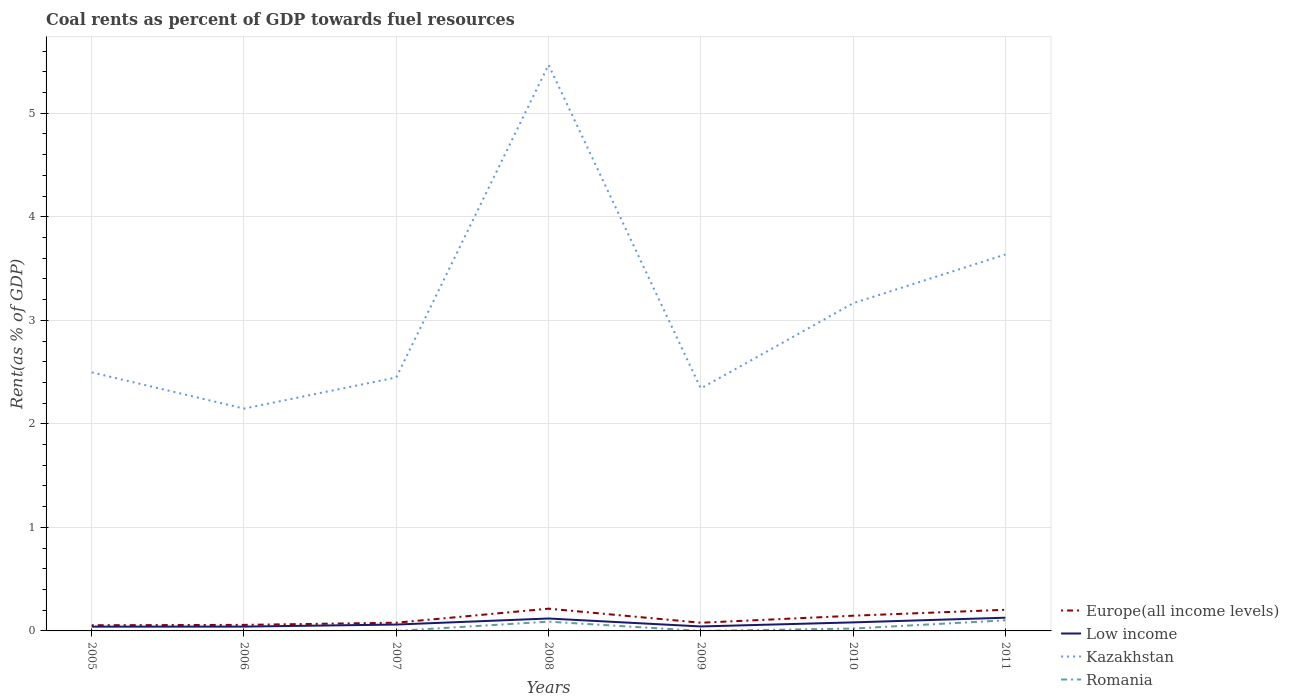Does the line corresponding to Europe(all income levels) intersect with the line corresponding to Low income?
Provide a short and direct response. No. Is the number of lines equal to the number of legend labels?
Offer a very short reply. Yes. Across all years, what is the maximum coal rent in Europe(all income levels)?
Ensure brevity in your answer.  0.05. In which year was the coal rent in Romania maximum?
Your answer should be very brief. 2006. What is the total coal rent in Europe(all income levels) in the graph?
Ensure brevity in your answer.  -0.02. What is the difference between the highest and the second highest coal rent in Europe(all income levels)?
Make the answer very short. 0.16. Is the coal rent in Low income strictly greater than the coal rent in Kazakhstan over the years?
Your answer should be compact. Yes. How many lines are there?
Give a very brief answer. 4. How many years are there in the graph?
Offer a terse response. 7. What is the difference between two consecutive major ticks on the Y-axis?
Offer a very short reply. 1. Does the graph contain grids?
Make the answer very short. Yes. Where does the legend appear in the graph?
Keep it short and to the point. Bottom right. How many legend labels are there?
Provide a succinct answer. 4. What is the title of the graph?
Your answer should be very brief. Coal rents as percent of GDP towards fuel resources. What is the label or title of the X-axis?
Your answer should be very brief. Years. What is the label or title of the Y-axis?
Provide a short and direct response. Rent(as % of GDP). What is the Rent(as % of GDP) of Europe(all income levels) in 2005?
Make the answer very short. 0.05. What is the Rent(as % of GDP) in Low income in 2005?
Provide a succinct answer. 0.04. What is the Rent(as % of GDP) in Kazakhstan in 2005?
Offer a terse response. 2.5. What is the Rent(as % of GDP) in Romania in 2005?
Offer a terse response. 8.7275933629083e-5. What is the Rent(as % of GDP) of Europe(all income levels) in 2006?
Your answer should be compact. 0.06. What is the Rent(as % of GDP) of Low income in 2006?
Offer a very short reply. 0.04. What is the Rent(as % of GDP) in Kazakhstan in 2006?
Provide a short and direct response. 2.15. What is the Rent(as % of GDP) in Romania in 2006?
Provide a succinct answer. 7.42123758365009e-5. What is the Rent(as % of GDP) in Europe(all income levels) in 2007?
Ensure brevity in your answer.  0.08. What is the Rent(as % of GDP) of Low income in 2007?
Provide a succinct answer. 0.06. What is the Rent(as % of GDP) in Kazakhstan in 2007?
Provide a short and direct response. 2.45. What is the Rent(as % of GDP) in Romania in 2007?
Ensure brevity in your answer.  9.89979329873995e-5. What is the Rent(as % of GDP) in Europe(all income levels) in 2008?
Your answer should be very brief. 0.21. What is the Rent(as % of GDP) in Low income in 2008?
Provide a short and direct response. 0.12. What is the Rent(as % of GDP) in Kazakhstan in 2008?
Provide a succinct answer. 5.47. What is the Rent(as % of GDP) of Romania in 2008?
Keep it short and to the point. 0.09. What is the Rent(as % of GDP) in Europe(all income levels) in 2009?
Your response must be concise. 0.08. What is the Rent(as % of GDP) of Low income in 2009?
Make the answer very short. 0.04. What is the Rent(as % of GDP) in Kazakhstan in 2009?
Your response must be concise. 2.34. What is the Rent(as % of GDP) in Romania in 2009?
Keep it short and to the point. 9.91154234092374e-5. What is the Rent(as % of GDP) of Europe(all income levels) in 2010?
Ensure brevity in your answer.  0.15. What is the Rent(as % of GDP) in Low income in 2010?
Keep it short and to the point. 0.08. What is the Rent(as % of GDP) in Kazakhstan in 2010?
Your answer should be compact. 3.16. What is the Rent(as % of GDP) of Romania in 2010?
Ensure brevity in your answer.  0.02. What is the Rent(as % of GDP) in Europe(all income levels) in 2011?
Provide a short and direct response. 0.2. What is the Rent(as % of GDP) in Low income in 2011?
Your response must be concise. 0.13. What is the Rent(as % of GDP) of Kazakhstan in 2011?
Provide a succinct answer. 3.64. What is the Rent(as % of GDP) of Romania in 2011?
Make the answer very short. 0.1. Across all years, what is the maximum Rent(as % of GDP) of Europe(all income levels)?
Ensure brevity in your answer.  0.21. Across all years, what is the maximum Rent(as % of GDP) in Low income?
Provide a succinct answer. 0.13. Across all years, what is the maximum Rent(as % of GDP) in Kazakhstan?
Your response must be concise. 5.47. Across all years, what is the maximum Rent(as % of GDP) in Romania?
Your answer should be compact. 0.1. Across all years, what is the minimum Rent(as % of GDP) of Europe(all income levels)?
Ensure brevity in your answer.  0.05. Across all years, what is the minimum Rent(as % of GDP) in Low income?
Your answer should be compact. 0.04. Across all years, what is the minimum Rent(as % of GDP) of Kazakhstan?
Your answer should be very brief. 2.15. Across all years, what is the minimum Rent(as % of GDP) in Romania?
Give a very brief answer. 7.42123758365009e-5. What is the total Rent(as % of GDP) in Europe(all income levels) in the graph?
Give a very brief answer. 0.84. What is the total Rent(as % of GDP) in Low income in the graph?
Give a very brief answer. 0.52. What is the total Rent(as % of GDP) of Kazakhstan in the graph?
Keep it short and to the point. 21.7. What is the total Rent(as % of GDP) of Romania in the graph?
Your response must be concise. 0.22. What is the difference between the Rent(as % of GDP) in Europe(all income levels) in 2005 and that in 2006?
Make the answer very short. -0. What is the difference between the Rent(as % of GDP) in Low income in 2005 and that in 2006?
Ensure brevity in your answer.  -0. What is the difference between the Rent(as % of GDP) of Kazakhstan in 2005 and that in 2006?
Provide a short and direct response. 0.35. What is the difference between the Rent(as % of GDP) in Europe(all income levels) in 2005 and that in 2007?
Provide a succinct answer. -0.02. What is the difference between the Rent(as % of GDP) of Low income in 2005 and that in 2007?
Make the answer very short. -0.02. What is the difference between the Rent(as % of GDP) in Kazakhstan in 2005 and that in 2007?
Provide a short and direct response. 0.05. What is the difference between the Rent(as % of GDP) of Romania in 2005 and that in 2007?
Make the answer very short. -0. What is the difference between the Rent(as % of GDP) in Europe(all income levels) in 2005 and that in 2008?
Your answer should be very brief. -0.16. What is the difference between the Rent(as % of GDP) in Low income in 2005 and that in 2008?
Provide a short and direct response. -0.08. What is the difference between the Rent(as % of GDP) in Kazakhstan in 2005 and that in 2008?
Provide a short and direct response. -2.97. What is the difference between the Rent(as % of GDP) of Romania in 2005 and that in 2008?
Keep it short and to the point. -0.09. What is the difference between the Rent(as % of GDP) of Europe(all income levels) in 2005 and that in 2009?
Provide a short and direct response. -0.02. What is the difference between the Rent(as % of GDP) of Low income in 2005 and that in 2009?
Your answer should be compact. -0. What is the difference between the Rent(as % of GDP) of Kazakhstan in 2005 and that in 2009?
Provide a short and direct response. 0.16. What is the difference between the Rent(as % of GDP) in Romania in 2005 and that in 2009?
Offer a very short reply. -0. What is the difference between the Rent(as % of GDP) in Europe(all income levels) in 2005 and that in 2010?
Keep it short and to the point. -0.09. What is the difference between the Rent(as % of GDP) of Low income in 2005 and that in 2010?
Give a very brief answer. -0.04. What is the difference between the Rent(as % of GDP) of Kazakhstan in 2005 and that in 2010?
Offer a very short reply. -0.67. What is the difference between the Rent(as % of GDP) in Romania in 2005 and that in 2010?
Your answer should be very brief. -0.02. What is the difference between the Rent(as % of GDP) in Europe(all income levels) in 2005 and that in 2011?
Keep it short and to the point. -0.15. What is the difference between the Rent(as % of GDP) of Low income in 2005 and that in 2011?
Offer a terse response. -0.09. What is the difference between the Rent(as % of GDP) in Kazakhstan in 2005 and that in 2011?
Offer a very short reply. -1.14. What is the difference between the Rent(as % of GDP) of Romania in 2005 and that in 2011?
Offer a very short reply. -0.1. What is the difference between the Rent(as % of GDP) in Europe(all income levels) in 2006 and that in 2007?
Give a very brief answer. -0.02. What is the difference between the Rent(as % of GDP) of Low income in 2006 and that in 2007?
Provide a succinct answer. -0.02. What is the difference between the Rent(as % of GDP) of Kazakhstan in 2006 and that in 2007?
Your response must be concise. -0.3. What is the difference between the Rent(as % of GDP) in Europe(all income levels) in 2006 and that in 2008?
Offer a terse response. -0.16. What is the difference between the Rent(as % of GDP) in Low income in 2006 and that in 2008?
Offer a terse response. -0.08. What is the difference between the Rent(as % of GDP) in Kazakhstan in 2006 and that in 2008?
Offer a terse response. -3.32. What is the difference between the Rent(as % of GDP) of Romania in 2006 and that in 2008?
Provide a short and direct response. -0.09. What is the difference between the Rent(as % of GDP) in Europe(all income levels) in 2006 and that in 2009?
Provide a short and direct response. -0.02. What is the difference between the Rent(as % of GDP) in Low income in 2006 and that in 2009?
Your answer should be very brief. -0. What is the difference between the Rent(as % of GDP) of Kazakhstan in 2006 and that in 2009?
Your answer should be compact. -0.19. What is the difference between the Rent(as % of GDP) of Romania in 2006 and that in 2009?
Provide a succinct answer. -0. What is the difference between the Rent(as % of GDP) of Europe(all income levels) in 2006 and that in 2010?
Give a very brief answer. -0.09. What is the difference between the Rent(as % of GDP) of Low income in 2006 and that in 2010?
Your response must be concise. -0.04. What is the difference between the Rent(as % of GDP) of Kazakhstan in 2006 and that in 2010?
Your answer should be very brief. -1.02. What is the difference between the Rent(as % of GDP) in Romania in 2006 and that in 2010?
Provide a succinct answer. -0.02. What is the difference between the Rent(as % of GDP) of Europe(all income levels) in 2006 and that in 2011?
Give a very brief answer. -0.15. What is the difference between the Rent(as % of GDP) in Low income in 2006 and that in 2011?
Make the answer very short. -0.09. What is the difference between the Rent(as % of GDP) of Kazakhstan in 2006 and that in 2011?
Keep it short and to the point. -1.49. What is the difference between the Rent(as % of GDP) of Romania in 2006 and that in 2011?
Provide a short and direct response. -0.1. What is the difference between the Rent(as % of GDP) of Europe(all income levels) in 2007 and that in 2008?
Provide a short and direct response. -0.14. What is the difference between the Rent(as % of GDP) in Low income in 2007 and that in 2008?
Offer a very short reply. -0.06. What is the difference between the Rent(as % of GDP) of Kazakhstan in 2007 and that in 2008?
Offer a very short reply. -3.02. What is the difference between the Rent(as % of GDP) in Romania in 2007 and that in 2008?
Make the answer very short. -0.09. What is the difference between the Rent(as % of GDP) in Low income in 2007 and that in 2009?
Ensure brevity in your answer.  0.02. What is the difference between the Rent(as % of GDP) in Kazakhstan in 2007 and that in 2009?
Your response must be concise. 0.11. What is the difference between the Rent(as % of GDP) in Europe(all income levels) in 2007 and that in 2010?
Provide a short and direct response. -0.07. What is the difference between the Rent(as % of GDP) in Low income in 2007 and that in 2010?
Your answer should be compact. -0.02. What is the difference between the Rent(as % of GDP) in Kazakhstan in 2007 and that in 2010?
Keep it short and to the point. -0.72. What is the difference between the Rent(as % of GDP) of Romania in 2007 and that in 2010?
Your response must be concise. -0.02. What is the difference between the Rent(as % of GDP) of Europe(all income levels) in 2007 and that in 2011?
Your answer should be very brief. -0.12. What is the difference between the Rent(as % of GDP) in Low income in 2007 and that in 2011?
Make the answer very short. -0.07. What is the difference between the Rent(as % of GDP) in Kazakhstan in 2007 and that in 2011?
Make the answer very short. -1.19. What is the difference between the Rent(as % of GDP) of Romania in 2007 and that in 2011?
Keep it short and to the point. -0.1. What is the difference between the Rent(as % of GDP) of Europe(all income levels) in 2008 and that in 2009?
Your response must be concise. 0.14. What is the difference between the Rent(as % of GDP) in Low income in 2008 and that in 2009?
Offer a very short reply. 0.08. What is the difference between the Rent(as % of GDP) in Kazakhstan in 2008 and that in 2009?
Offer a very short reply. 3.12. What is the difference between the Rent(as % of GDP) in Romania in 2008 and that in 2009?
Provide a short and direct response. 0.09. What is the difference between the Rent(as % of GDP) in Europe(all income levels) in 2008 and that in 2010?
Your answer should be very brief. 0.07. What is the difference between the Rent(as % of GDP) of Low income in 2008 and that in 2010?
Offer a very short reply. 0.04. What is the difference between the Rent(as % of GDP) of Kazakhstan in 2008 and that in 2010?
Provide a succinct answer. 2.3. What is the difference between the Rent(as % of GDP) in Romania in 2008 and that in 2010?
Your answer should be very brief. 0.07. What is the difference between the Rent(as % of GDP) in Europe(all income levels) in 2008 and that in 2011?
Offer a very short reply. 0.01. What is the difference between the Rent(as % of GDP) of Low income in 2008 and that in 2011?
Offer a terse response. -0.01. What is the difference between the Rent(as % of GDP) of Kazakhstan in 2008 and that in 2011?
Ensure brevity in your answer.  1.83. What is the difference between the Rent(as % of GDP) in Romania in 2008 and that in 2011?
Make the answer very short. -0.01. What is the difference between the Rent(as % of GDP) in Europe(all income levels) in 2009 and that in 2010?
Make the answer very short. -0.07. What is the difference between the Rent(as % of GDP) of Low income in 2009 and that in 2010?
Offer a terse response. -0.04. What is the difference between the Rent(as % of GDP) in Kazakhstan in 2009 and that in 2010?
Provide a succinct answer. -0.82. What is the difference between the Rent(as % of GDP) in Romania in 2009 and that in 2010?
Keep it short and to the point. -0.02. What is the difference between the Rent(as % of GDP) of Europe(all income levels) in 2009 and that in 2011?
Your answer should be very brief. -0.13. What is the difference between the Rent(as % of GDP) of Low income in 2009 and that in 2011?
Your answer should be very brief. -0.08. What is the difference between the Rent(as % of GDP) in Kazakhstan in 2009 and that in 2011?
Your answer should be very brief. -1.29. What is the difference between the Rent(as % of GDP) in Romania in 2009 and that in 2011?
Provide a short and direct response. -0.1. What is the difference between the Rent(as % of GDP) of Europe(all income levels) in 2010 and that in 2011?
Provide a short and direct response. -0.06. What is the difference between the Rent(as % of GDP) of Low income in 2010 and that in 2011?
Ensure brevity in your answer.  -0.05. What is the difference between the Rent(as % of GDP) of Kazakhstan in 2010 and that in 2011?
Make the answer very short. -0.47. What is the difference between the Rent(as % of GDP) in Romania in 2010 and that in 2011?
Your response must be concise. -0.08. What is the difference between the Rent(as % of GDP) in Europe(all income levels) in 2005 and the Rent(as % of GDP) in Low income in 2006?
Make the answer very short. 0.01. What is the difference between the Rent(as % of GDP) in Europe(all income levels) in 2005 and the Rent(as % of GDP) in Kazakhstan in 2006?
Ensure brevity in your answer.  -2.09. What is the difference between the Rent(as % of GDP) in Europe(all income levels) in 2005 and the Rent(as % of GDP) in Romania in 2006?
Make the answer very short. 0.05. What is the difference between the Rent(as % of GDP) in Low income in 2005 and the Rent(as % of GDP) in Kazakhstan in 2006?
Your response must be concise. -2.11. What is the difference between the Rent(as % of GDP) of Low income in 2005 and the Rent(as % of GDP) of Romania in 2006?
Make the answer very short. 0.04. What is the difference between the Rent(as % of GDP) of Kazakhstan in 2005 and the Rent(as % of GDP) of Romania in 2006?
Your answer should be compact. 2.5. What is the difference between the Rent(as % of GDP) of Europe(all income levels) in 2005 and the Rent(as % of GDP) of Low income in 2007?
Provide a short and direct response. -0.01. What is the difference between the Rent(as % of GDP) in Europe(all income levels) in 2005 and the Rent(as % of GDP) in Kazakhstan in 2007?
Provide a succinct answer. -2.39. What is the difference between the Rent(as % of GDP) in Europe(all income levels) in 2005 and the Rent(as % of GDP) in Romania in 2007?
Give a very brief answer. 0.05. What is the difference between the Rent(as % of GDP) of Low income in 2005 and the Rent(as % of GDP) of Kazakhstan in 2007?
Make the answer very short. -2.41. What is the difference between the Rent(as % of GDP) in Low income in 2005 and the Rent(as % of GDP) in Romania in 2007?
Your response must be concise. 0.04. What is the difference between the Rent(as % of GDP) in Kazakhstan in 2005 and the Rent(as % of GDP) in Romania in 2007?
Your response must be concise. 2.5. What is the difference between the Rent(as % of GDP) in Europe(all income levels) in 2005 and the Rent(as % of GDP) in Low income in 2008?
Keep it short and to the point. -0.07. What is the difference between the Rent(as % of GDP) of Europe(all income levels) in 2005 and the Rent(as % of GDP) of Kazakhstan in 2008?
Your answer should be compact. -5.41. What is the difference between the Rent(as % of GDP) in Europe(all income levels) in 2005 and the Rent(as % of GDP) in Romania in 2008?
Provide a short and direct response. -0.03. What is the difference between the Rent(as % of GDP) in Low income in 2005 and the Rent(as % of GDP) in Kazakhstan in 2008?
Offer a very short reply. -5.43. What is the difference between the Rent(as % of GDP) in Low income in 2005 and the Rent(as % of GDP) in Romania in 2008?
Give a very brief answer. -0.05. What is the difference between the Rent(as % of GDP) in Kazakhstan in 2005 and the Rent(as % of GDP) in Romania in 2008?
Provide a succinct answer. 2.41. What is the difference between the Rent(as % of GDP) in Europe(all income levels) in 2005 and the Rent(as % of GDP) in Low income in 2009?
Keep it short and to the point. 0.01. What is the difference between the Rent(as % of GDP) of Europe(all income levels) in 2005 and the Rent(as % of GDP) of Kazakhstan in 2009?
Give a very brief answer. -2.29. What is the difference between the Rent(as % of GDP) of Europe(all income levels) in 2005 and the Rent(as % of GDP) of Romania in 2009?
Provide a succinct answer. 0.05. What is the difference between the Rent(as % of GDP) of Low income in 2005 and the Rent(as % of GDP) of Kazakhstan in 2009?
Offer a terse response. -2.3. What is the difference between the Rent(as % of GDP) of Low income in 2005 and the Rent(as % of GDP) of Romania in 2009?
Provide a succinct answer. 0.04. What is the difference between the Rent(as % of GDP) of Kazakhstan in 2005 and the Rent(as % of GDP) of Romania in 2009?
Make the answer very short. 2.5. What is the difference between the Rent(as % of GDP) in Europe(all income levels) in 2005 and the Rent(as % of GDP) in Low income in 2010?
Give a very brief answer. -0.03. What is the difference between the Rent(as % of GDP) of Europe(all income levels) in 2005 and the Rent(as % of GDP) of Kazakhstan in 2010?
Keep it short and to the point. -3.11. What is the difference between the Rent(as % of GDP) in Europe(all income levels) in 2005 and the Rent(as % of GDP) in Romania in 2010?
Your answer should be very brief. 0.03. What is the difference between the Rent(as % of GDP) in Low income in 2005 and the Rent(as % of GDP) in Kazakhstan in 2010?
Offer a very short reply. -3.12. What is the difference between the Rent(as % of GDP) of Low income in 2005 and the Rent(as % of GDP) of Romania in 2010?
Your response must be concise. 0.02. What is the difference between the Rent(as % of GDP) in Kazakhstan in 2005 and the Rent(as % of GDP) in Romania in 2010?
Provide a short and direct response. 2.47. What is the difference between the Rent(as % of GDP) in Europe(all income levels) in 2005 and the Rent(as % of GDP) in Low income in 2011?
Make the answer very short. -0.07. What is the difference between the Rent(as % of GDP) in Europe(all income levels) in 2005 and the Rent(as % of GDP) in Kazakhstan in 2011?
Keep it short and to the point. -3.58. What is the difference between the Rent(as % of GDP) in Europe(all income levels) in 2005 and the Rent(as % of GDP) in Romania in 2011?
Give a very brief answer. -0.05. What is the difference between the Rent(as % of GDP) of Low income in 2005 and the Rent(as % of GDP) of Kazakhstan in 2011?
Make the answer very short. -3.59. What is the difference between the Rent(as % of GDP) in Low income in 2005 and the Rent(as % of GDP) in Romania in 2011?
Ensure brevity in your answer.  -0.06. What is the difference between the Rent(as % of GDP) of Kazakhstan in 2005 and the Rent(as % of GDP) of Romania in 2011?
Your response must be concise. 2.39. What is the difference between the Rent(as % of GDP) in Europe(all income levels) in 2006 and the Rent(as % of GDP) in Low income in 2007?
Offer a very short reply. -0. What is the difference between the Rent(as % of GDP) of Europe(all income levels) in 2006 and the Rent(as % of GDP) of Kazakhstan in 2007?
Ensure brevity in your answer.  -2.39. What is the difference between the Rent(as % of GDP) of Europe(all income levels) in 2006 and the Rent(as % of GDP) of Romania in 2007?
Provide a short and direct response. 0.06. What is the difference between the Rent(as % of GDP) in Low income in 2006 and the Rent(as % of GDP) in Kazakhstan in 2007?
Make the answer very short. -2.41. What is the difference between the Rent(as % of GDP) of Low income in 2006 and the Rent(as % of GDP) of Romania in 2007?
Ensure brevity in your answer.  0.04. What is the difference between the Rent(as % of GDP) of Kazakhstan in 2006 and the Rent(as % of GDP) of Romania in 2007?
Ensure brevity in your answer.  2.15. What is the difference between the Rent(as % of GDP) of Europe(all income levels) in 2006 and the Rent(as % of GDP) of Low income in 2008?
Your response must be concise. -0.06. What is the difference between the Rent(as % of GDP) of Europe(all income levels) in 2006 and the Rent(as % of GDP) of Kazakhstan in 2008?
Keep it short and to the point. -5.41. What is the difference between the Rent(as % of GDP) of Europe(all income levels) in 2006 and the Rent(as % of GDP) of Romania in 2008?
Make the answer very short. -0.03. What is the difference between the Rent(as % of GDP) in Low income in 2006 and the Rent(as % of GDP) in Kazakhstan in 2008?
Your answer should be compact. -5.43. What is the difference between the Rent(as % of GDP) in Low income in 2006 and the Rent(as % of GDP) in Romania in 2008?
Ensure brevity in your answer.  -0.05. What is the difference between the Rent(as % of GDP) in Kazakhstan in 2006 and the Rent(as % of GDP) in Romania in 2008?
Give a very brief answer. 2.06. What is the difference between the Rent(as % of GDP) of Europe(all income levels) in 2006 and the Rent(as % of GDP) of Low income in 2009?
Offer a very short reply. 0.02. What is the difference between the Rent(as % of GDP) of Europe(all income levels) in 2006 and the Rent(as % of GDP) of Kazakhstan in 2009?
Make the answer very short. -2.28. What is the difference between the Rent(as % of GDP) of Europe(all income levels) in 2006 and the Rent(as % of GDP) of Romania in 2009?
Offer a very short reply. 0.06. What is the difference between the Rent(as % of GDP) in Low income in 2006 and the Rent(as % of GDP) in Kazakhstan in 2009?
Offer a terse response. -2.3. What is the difference between the Rent(as % of GDP) of Low income in 2006 and the Rent(as % of GDP) of Romania in 2009?
Your response must be concise. 0.04. What is the difference between the Rent(as % of GDP) in Kazakhstan in 2006 and the Rent(as % of GDP) in Romania in 2009?
Offer a very short reply. 2.15. What is the difference between the Rent(as % of GDP) of Europe(all income levels) in 2006 and the Rent(as % of GDP) of Low income in 2010?
Keep it short and to the point. -0.02. What is the difference between the Rent(as % of GDP) in Europe(all income levels) in 2006 and the Rent(as % of GDP) in Kazakhstan in 2010?
Your response must be concise. -3.11. What is the difference between the Rent(as % of GDP) in Europe(all income levels) in 2006 and the Rent(as % of GDP) in Romania in 2010?
Keep it short and to the point. 0.04. What is the difference between the Rent(as % of GDP) of Low income in 2006 and the Rent(as % of GDP) of Kazakhstan in 2010?
Make the answer very short. -3.12. What is the difference between the Rent(as % of GDP) in Low income in 2006 and the Rent(as % of GDP) in Romania in 2010?
Offer a terse response. 0.02. What is the difference between the Rent(as % of GDP) of Kazakhstan in 2006 and the Rent(as % of GDP) of Romania in 2010?
Your answer should be compact. 2.12. What is the difference between the Rent(as % of GDP) in Europe(all income levels) in 2006 and the Rent(as % of GDP) in Low income in 2011?
Your answer should be very brief. -0.07. What is the difference between the Rent(as % of GDP) of Europe(all income levels) in 2006 and the Rent(as % of GDP) of Kazakhstan in 2011?
Make the answer very short. -3.58. What is the difference between the Rent(as % of GDP) of Europe(all income levels) in 2006 and the Rent(as % of GDP) of Romania in 2011?
Your answer should be compact. -0.04. What is the difference between the Rent(as % of GDP) in Low income in 2006 and the Rent(as % of GDP) in Kazakhstan in 2011?
Keep it short and to the point. -3.59. What is the difference between the Rent(as % of GDP) of Low income in 2006 and the Rent(as % of GDP) of Romania in 2011?
Make the answer very short. -0.06. What is the difference between the Rent(as % of GDP) in Kazakhstan in 2006 and the Rent(as % of GDP) in Romania in 2011?
Provide a short and direct response. 2.04. What is the difference between the Rent(as % of GDP) of Europe(all income levels) in 2007 and the Rent(as % of GDP) of Low income in 2008?
Provide a succinct answer. -0.04. What is the difference between the Rent(as % of GDP) in Europe(all income levels) in 2007 and the Rent(as % of GDP) in Kazakhstan in 2008?
Provide a succinct answer. -5.39. What is the difference between the Rent(as % of GDP) in Europe(all income levels) in 2007 and the Rent(as % of GDP) in Romania in 2008?
Ensure brevity in your answer.  -0.01. What is the difference between the Rent(as % of GDP) of Low income in 2007 and the Rent(as % of GDP) of Kazakhstan in 2008?
Provide a short and direct response. -5.41. What is the difference between the Rent(as % of GDP) in Low income in 2007 and the Rent(as % of GDP) in Romania in 2008?
Your response must be concise. -0.03. What is the difference between the Rent(as % of GDP) in Kazakhstan in 2007 and the Rent(as % of GDP) in Romania in 2008?
Offer a terse response. 2.36. What is the difference between the Rent(as % of GDP) in Europe(all income levels) in 2007 and the Rent(as % of GDP) in Low income in 2009?
Your answer should be very brief. 0.04. What is the difference between the Rent(as % of GDP) in Europe(all income levels) in 2007 and the Rent(as % of GDP) in Kazakhstan in 2009?
Make the answer very short. -2.26. What is the difference between the Rent(as % of GDP) in Europe(all income levels) in 2007 and the Rent(as % of GDP) in Romania in 2009?
Keep it short and to the point. 0.08. What is the difference between the Rent(as % of GDP) in Low income in 2007 and the Rent(as % of GDP) in Kazakhstan in 2009?
Give a very brief answer. -2.28. What is the difference between the Rent(as % of GDP) in Low income in 2007 and the Rent(as % of GDP) in Romania in 2009?
Give a very brief answer. 0.06. What is the difference between the Rent(as % of GDP) of Kazakhstan in 2007 and the Rent(as % of GDP) of Romania in 2009?
Offer a very short reply. 2.45. What is the difference between the Rent(as % of GDP) of Europe(all income levels) in 2007 and the Rent(as % of GDP) of Low income in 2010?
Your answer should be compact. -0. What is the difference between the Rent(as % of GDP) in Europe(all income levels) in 2007 and the Rent(as % of GDP) in Kazakhstan in 2010?
Give a very brief answer. -3.09. What is the difference between the Rent(as % of GDP) in Europe(all income levels) in 2007 and the Rent(as % of GDP) in Romania in 2010?
Keep it short and to the point. 0.06. What is the difference between the Rent(as % of GDP) of Low income in 2007 and the Rent(as % of GDP) of Kazakhstan in 2010?
Ensure brevity in your answer.  -3.1. What is the difference between the Rent(as % of GDP) in Low income in 2007 and the Rent(as % of GDP) in Romania in 2010?
Your answer should be compact. 0.04. What is the difference between the Rent(as % of GDP) of Kazakhstan in 2007 and the Rent(as % of GDP) of Romania in 2010?
Provide a short and direct response. 2.43. What is the difference between the Rent(as % of GDP) of Europe(all income levels) in 2007 and the Rent(as % of GDP) of Low income in 2011?
Provide a succinct answer. -0.05. What is the difference between the Rent(as % of GDP) in Europe(all income levels) in 2007 and the Rent(as % of GDP) in Kazakhstan in 2011?
Your answer should be compact. -3.56. What is the difference between the Rent(as % of GDP) of Europe(all income levels) in 2007 and the Rent(as % of GDP) of Romania in 2011?
Keep it short and to the point. -0.02. What is the difference between the Rent(as % of GDP) of Low income in 2007 and the Rent(as % of GDP) of Kazakhstan in 2011?
Keep it short and to the point. -3.57. What is the difference between the Rent(as % of GDP) of Low income in 2007 and the Rent(as % of GDP) of Romania in 2011?
Make the answer very short. -0.04. What is the difference between the Rent(as % of GDP) of Kazakhstan in 2007 and the Rent(as % of GDP) of Romania in 2011?
Give a very brief answer. 2.35. What is the difference between the Rent(as % of GDP) of Europe(all income levels) in 2008 and the Rent(as % of GDP) of Low income in 2009?
Your response must be concise. 0.17. What is the difference between the Rent(as % of GDP) of Europe(all income levels) in 2008 and the Rent(as % of GDP) of Kazakhstan in 2009?
Your answer should be very brief. -2.13. What is the difference between the Rent(as % of GDP) in Europe(all income levels) in 2008 and the Rent(as % of GDP) in Romania in 2009?
Your answer should be very brief. 0.21. What is the difference between the Rent(as % of GDP) of Low income in 2008 and the Rent(as % of GDP) of Kazakhstan in 2009?
Provide a succinct answer. -2.22. What is the difference between the Rent(as % of GDP) of Low income in 2008 and the Rent(as % of GDP) of Romania in 2009?
Offer a very short reply. 0.12. What is the difference between the Rent(as % of GDP) of Kazakhstan in 2008 and the Rent(as % of GDP) of Romania in 2009?
Ensure brevity in your answer.  5.47. What is the difference between the Rent(as % of GDP) of Europe(all income levels) in 2008 and the Rent(as % of GDP) of Low income in 2010?
Provide a succinct answer. 0.13. What is the difference between the Rent(as % of GDP) of Europe(all income levels) in 2008 and the Rent(as % of GDP) of Kazakhstan in 2010?
Your answer should be compact. -2.95. What is the difference between the Rent(as % of GDP) in Europe(all income levels) in 2008 and the Rent(as % of GDP) in Romania in 2010?
Your answer should be very brief. 0.19. What is the difference between the Rent(as % of GDP) of Low income in 2008 and the Rent(as % of GDP) of Kazakhstan in 2010?
Offer a terse response. -3.04. What is the difference between the Rent(as % of GDP) of Low income in 2008 and the Rent(as % of GDP) of Romania in 2010?
Offer a very short reply. 0.1. What is the difference between the Rent(as % of GDP) in Kazakhstan in 2008 and the Rent(as % of GDP) in Romania in 2010?
Provide a short and direct response. 5.44. What is the difference between the Rent(as % of GDP) in Europe(all income levels) in 2008 and the Rent(as % of GDP) in Low income in 2011?
Your answer should be compact. 0.09. What is the difference between the Rent(as % of GDP) in Europe(all income levels) in 2008 and the Rent(as % of GDP) in Kazakhstan in 2011?
Ensure brevity in your answer.  -3.42. What is the difference between the Rent(as % of GDP) of Europe(all income levels) in 2008 and the Rent(as % of GDP) of Romania in 2011?
Provide a succinct answer. 0.11. What is the difference between the Rent(as % of GDP) of Low income in 2008 and the Rent(as % of GDP) of Kazakhstan in 2011?
Provide a short and direct response. -3.52. What is the difference between the Rent(as % of GDP) in Low income in 2008 and the Rent(as % of GDP) in Romania in 2011?
Keep it short and to the point. 0.02. What is the difference between the Rent(as % of GDP) of Kazakhstan in 2008 and the Rent(as % of GDP) of Romania in 2011?
Keep it short and to the point. 5.36. What is the difference between the Rent(as % of GDP) of Europe(all income levels) in 2009 and the Rent(as % of GDP) of Low income in 2010?
Ensure brevity in your answer.  -0. What is the difference between the Rent(as % of GDP) of Europe(all income levels) in 2009 and the Rent(as % of GDP) of Kazakhstan in 2010?
Offer a terse response. -3.09. What is the difference between the Rent(as % of GDP) in Europe(all income levels) in 2009 and the Rent(as % of GDP) in Romania in 2010?
Your answer should be compact. 0.06. What is the difference between the Rent(as % of GDP) in Low income in 2009 and the Rent(as % of GDP) in Kazakhstan in 2010?
Ensure brevity in your answer.  -3.12. What is the difference between the Rent(as % of GDP) of Low income in 2009 and the Rent(as % of GDP) of Romania in 2010?
Offer a very short reply. 0.02. What is the difference between the Rent(as % of GDP) of Kazakhstan in 2009 and the Rent(as % of GDP) of Romania in 2010?
Make the answer very short. 2.32. What is the difference between the Rent(as % of GDP) of Europe(all income levels) in 2009 and the Rent(as % of GDP) of Low income in 2011?
Your answer should be compact. -0.05. What is the difference between the Rent(as % of GDP) of Europe(all income levels) in 2009 and the Rent(as % of GDP) of Kazakhstan in 2011?
Your answer should be compact. -3.56. What is the difference between the Rent(as % of GDP) in Europe(all income levels) in 2009 and the Rent(as % of GDP) in Romania in 2011?
Give a very brief answer. -0.02. What is the difference between the Rent(as % of GDP) of Low income in 2009 and the Rent(as % of GDP) of Kazakhstan in 2011?
Your response must be concise. -3.59. What is the difference between the Rent(as % of GDP) in Low income in 2009 and the Rent(as % of GDP) in Romania in 2011?
Your answer should be compact. -0.06. What is the difference between the Rent(as % of GDP) in Kazakhstan in 2009 and the Rent(as % of GDP) in Romania in 2011?
Your response must be concise. 2.24. What is the difference between the Rent(as % of GDP) in Europe(all income levels) in 2010 and the Rent(as % of GDP) in Low income in 2011?
Your response must be concise. 0.02. What is the difference between the Rent(as % of GDP) of Europe(all income levels) in 2010 and the Rent(as % of GDP) of Kazakhstan in 2011?
Offer a very short reply. -3.49. What is the difference between the Rent(as % of GDP) of Europe(all income levels) in 2010 and the Rent(as % of GDP) of Romania in 2011?
Provide a short and direct response. 0.04. What is the difference between the Rent(as % of GDP) in Low income in 2010 and the Rent(as % of GDP) in Kazakhstan in 2011?
Ensure brevity in your answer.  -3.55. What is the difference between the Rent(as % of GDP) in Low income in 2010 and the Rent(as % of GDP) in Romania in 2011?
Your answer should be compact. -0.02. What is the difference between the Rent(as % of GDP) of Kazakhstan in 2010 and the Rent(as % of GDP) of Romania in 2011?
Make the answer very short. 3.06. What is the average Rent(as % of GDP) in Europe(all income levels) per year?
Your answer should be very brief. 0.12. What is the average Rent(as % of GDP) in Low income per year?
Your answer should be very brief. 0.07. What is the average Rent(as % of GDP) of Kazakhstan per year?
Your answer should be very brief. 3.1. What is the average Rent(as % of GDP) in Romania per year?
Provide a short and direct response. 0.03. In the year 2005, what is the difference between the Rent(as % of GDP) in Europe(all income levels) and Rent(as % of GDP) in Low income?
Your response must be concise. 0.01. In the year 2005, what is the difference between the Rent(as % of GDP) of Europe(all income levels) and Rent(as % of GDP) of Kazakhstan?
Your response must be concise. -2.44. In the year 2005, what is the difference between the Rent(as % of GDP) of Europe(all income levels) and Rent(as % of GDP) of Romania?
Provide a short and direct response. 0.05. In the year 2005, what is the difference between the Rent(as % of GDP) of Low income and Rent(as % of GDP) of Kazakhstan?
Offer a very short reply. -2.46. In the year 2005, what is the difference between the Rent(as % of GDP) of Low income and Rent(as % of GDP) of Romania?
Your response must be concise. 0.04. In the year 2005, what is the difference between the Rent(as % of GDP) in Kazakhstan and Rent(as % of GDP) in Romania?
Provide a succinct answer. 2.5. In the year 2006, what is the difference between the Rent(as % of GDP) in Europe(all income levels) and Rent(as % of GDP) in Low income?
Offer a terse response. 0.02. In the year 2006, what is the difference between the Rent(as % of GDP) in Europe(all income levels) and Rent(as % of GDP) in Kazakhstan?
Keep it short and to the point. -2.09. In the year 2006, what is the difference between the Rent(as % of GDP) in Europe(all income levels) and Rent(as % of GDP) in Romania?
Your response must be concise. 0.06. In the year 2006, what is the difference between the Rent(as % of GDP) in Low income and Rent(as % of GDP) in Kazakhstan?
Your answer should be very brief. -2.11. In the year 2006, what is the difference between the Rent(as % of GDP) in Low income and Rent(as % of GDP) in Romania?
Give a very brief answer. 0.04. In the year 2006, what is the difference between the Rent(as % of GDP) of Kazakhstan and Rent(as % of GDP) of Romania?
Ensure brevity in your answer.  2.15. In the year 2007, what is the difference between the Rent(as % of GDP) in Europe(all income levels) and Rent(as % of GDP) in Low income?
Provide a short and direct response. 0.02. In the year 2007, what is the difference between the Rent(as % of GDP) of Europe(all income levels) and Rent(as % of GDP) of Kazakhstan?
Provide a short and direct response. -2.37. In the year 2007, what is the difference between the Rent(as % of GDP) of Europe(all income levels) and Rent(as % of GDP) of Romania?
Offer a very short reply. 0.08. In the year 2007, what is the difference between the Rent(as % of GDP) in Low income and Rent(as % of GDP) in Kazakhstan?
Your response must be concise. -2.39. In the year 2007, what is the difference between the Rent(as % of GDP) in Low income and Rent(as % of GDP) in Romania?
Keep it short and to the point. 0.06. In the year 2007, what is the difference between the Rent(as % of GDP) in Kazakhstan and Rent(as % of GDP) in Romania?
Your answer should be very brief. 2.45. In the year 2008, what is the difference between the Rent(as % of GDP) in Europe(all income levels) and Rent(as % of GDP) in Low income?
Your answer should be compact. 0.09. In the year 2008, what is the difference between the Rent(as % of GDP) of Europe(all income levels) and Rent(as % of GDP) of Kazakhstan?
Offer a terse response. -5.25. In the year 2008, what is the difference between the Rent(as % of GDP) of Europe(all income levels) and Rent(as % of GDP) of Romania?
Make the answer very short. 0.13. In the year 2008, what is the difference between the Rent(as % of GDP) of Low income and Rent(as % of GDP) of Kazakhstan?
Offer a terse response. -5.35. In the year 2008, what is the difference between the Rent(as % of GDP) in Low income and Rent(as % of GDP) in Romania?
Your response must be concise. 0.03. In the year 2008, what is the difference between the Rent(as % of GDP) of Kazakhstan and Rent(as % of GDP) of Romania?
Your answer should be compact. 5.38. In the year 2009, what is the difference between the Rent(as % of GDP) of Europe(all income levels) and Rent(as % of GDP) of Low income?
Offer a terse response. 0.04. In the year 2009, what is the difference between the Rent(as % of GDP) of Europe(all income levels) and Rent(as % of GDP) of Kazakhstan?
Provide a succinct answer. -2.26. In the year 2009, what is the difference between the Rent(as % of GDP) in Europe(all income levels) and Rent(as % of GDP) in Romania?
Give a very brief answer. 0.08. In the year 2009, what is the difference between the Rent(as % of GDP) in Low income and Rent(as % of GDP) in Kazakhstan?
Give a very brief answer. -2.3. In the year 2009, what is the difference between the Rent(as % of GDP) in Low income and Rent(as % of GDP) in Romania?
Provide a short and direct response. 0.04. In the year 2009, what is the difference between the Rent(as % of GDP) in Kazakhstan and Rent(as % of GDP) in Romania?
Provide a succinct answer. 2.34. In the year 2010, what is the difference between the Rent(as % of GDP) in Europe(all income levels) and Rent(as % of GDP) in Low income?
Offer a terse response. 0.06. In the year 2010, what is the difference between the Rent(as % of GDP) in Europe(all income levels) and Rent(as % of GDP) in Kazakhstan?
Provide a short and direct response. -3.02. In the year 2010, what is the difference between the Rent(as % of GDP) in Europe(all income levels) and Rent(as % of GDP) in Romania?
Provide a succinct answer. 0.12. In the year 2010, what is the difference between the Rent(as % of GDP) in Low income and Rent(as % of GDP) in Kazakhstan?
Offer a very short reply. -3.08. In the year 2010, what is the difference between the Rent(as % of GDP) of Low income and Rent(as % of GDP) of Romania?
Offer a very short reply. 0.06. In the year 2010, what is the difference between the Rent(as % of GDP) of Kazakhstan and Rent(as % of GDP) of Romania?
Provide a succinct answer. 3.14. In the year 2011, what is the difference between the Rent(as % of GDP) of Europe(all income levels) and Rent(as % of GDP) of Low income?
Provide a succinct answer. 0.08. In the year 2011, what is the difference between the Rent(as % of GDP) in Europe(all income levels) and Rent(as % of GDP) in Kazakhstan?
Your answer should be compact. -3.43. In the year 2011, what is the difference between the Rent(as % of GDP) of Europe(all income levels) and Rent(as % of GDP) of Romania?
Make the answer very short. 0.1. In the year 2011, what is the difference between the Rent(as % of GDP) of Low income and Rent(as % of GDP) of Kazakhstan?
Your response must be concise. -3.51. In the year 2011, what is the difference between the Rent(as % of GDP) of Low income and Rent(as % of GDP) of Romania?
Your answer should be compact. 0.03. In the year 2011, what is the difference between the Rent(as % of GDP) of Kazakhstan and Rent(as % of GDP) of Romania?
Your answer should be compact. 3.53. What is the ratio of the Rent(as % of GDP) in Europe(all income levels) in 2005 to that in 2006?
Your answer should be compact. 0.94. What is the ratio of the Rent(as % of GDP) of Low income in 2005 to that in 2006?
Ensure brevity in your answer.  0.99. What is the ratio of the Rent(as % of GDP) of Kazakhstan in 2005 to that in 2006?
Make the answer very short. 1.16. What is the ratio of the Rent(as % of GDP) in Romania in 2005 to that in 2006?
Ensure brevity in your answer.  1.18. What is the ratio of the Rent(as % of GDP) of Europe(all income levels) in 2005 to that in 2007?
Your answer should be compact. 0.69. What is the ratio of the Rent(as % of GDP) of Low income in 2005 to that in 2007?
Offer a terse response. 0.67. What is the ratio of the Rent(as % of GDP) of Romania in 2005 to that in 2007?
Ensure brevity in your answer.  0.88. What is the ratio of the Rent(as % of GDP) of Europe(all income levels) in 2005 to that in 2008?
Ensure brevity in your answer.  0.26. What is the ratio of the Rent(as % of GDP) in Low income in 2005 to that in 2008?
Offer a very short reply. 0.34. What is the ratio of the Rent(as % of GDP) of Kazakhstan in 2005 to that in 2008?
Provide a short and direct response. 0.46. What is the ratio of the Rent(as % of GDP) of Europe(all income levels) in 2005 to that in 2009?
Keep it short and to the point. 0.69. What is the ratio of the Rent(as % of GDP) in Low income in 2005 to that in 2009?
Offer a terse response. 0.96. What is the ratio of the Rent(as % of GDP) of Kazakhstan in 2005 to that in 2009?
Provide a succinct answer. 1.07. What is the ratio of the Rent(as % of GDP) of Romania in 2005 to that in 2009?
Offer a terse response. 0.88. What is the ratio of the Rent(as % of GDP) in Europe(all income levels) in 2005 to that in 2010?
Offer a very short reply. 0.37. What is the ratio of the Rent(as % of GDP) in Low income in 2005 to that in 2010?
Your response must be concise. 0.5. What is the ratio of the Rent(as % of GDP) of Kazakhstan in 2005 to that in 2010?
Give a very brief answer. 0.79. What is the ratio of the Rent(as % of GDP) in Romania in 2005 to that in 2010?
Your answer should be very brief. 0. What is the ratio of the Rent(as % of GDP) in Europe(all income levels) in 2005 to that in 2011?
Your answer should be compact. 0.27. What is the ratio of the Rent(as % of GDP) of Low income in 2005 to that in 2011?
Your response must be concise. 0.32. What is the ratio of the Rent(as % of GDP) in Kazakhstan in 2005 to that in 2011?
Offer a terse response. 0.69. What is the ratio of the Rent(as % of GDP) of Romania in 2005 to that in 2011?
Keep it short and to the point. 0. What is the ratio of the Rent(as % of GDP) of Europe(all income levels) in 2006 to that in 2007?
Provide a short and direct response. 0.74. What is the ratio of the Rent(as % of GDP) in Low income in 2006 to that in 2007?
Your response must be concise. 0.68. What is the ratio of the Rent(as % of GDP) in Kazakhstan in 2006 to that in 2007?
Provide a short and direct response. 0.88. What is the ratio of the Rent(as % of GDP) of Romania in 2006 to that in 2007?
Provide a succinct answer. 0.75. What is the ratio of the Rent(as % of GDP) in Europe(all income levels) in 2006 to that in 2008?
Provide a succinct answer. 0.27. What is the ratio of the Rent(as % of GDP) of Low income in 2006 to that in 2008?
Offer a terse response. 0.35. What is the ratio of the Rent(as % of GDP) in Kazakhstan in 2006 to that in 2008?
Offer a terse response. 0.39. What is the ratio of the Rent(as % of GDP) in Romania in 2006 to that in 2008?
Your response must be concise. 0. What is the ratio of the Rent(as % of GDP) of Europe(all income levels) in 2006 to that in 2009?
Your response must be concise. 0.74. What is the ratio of the Rent(as % of GDP) of Low income in 2006 to that in 2009?
Offer a very short reply. 0.97. What is the ratio of the Rent(as % of GDP) in Kazakhstan in 2006 to that in 2009?
Make the answer very short. 0.92. What is the ratio of the Rent(as % of GDP) of Romania in 2006 to that in 2009?
Your answer should be compact. 0.75. What is the ratio of the Rent(as % of GDP) in Europe(all income levels) in 2006 to that in 2010?
Offer a very short reply. 0.4. What is the ratio of the Rent(as % of GDP) of Low income in 2006 to that in 2010?
Offer a very short reply. 0.51. What is the ratio of the Rent(as % of GDP) in Kazakhstan in 2006 to that in 2010?
Provide a succinct answer. 0.68. What is the ratio of the Rent(as % of GDP) in Romania in 2006 to that in 2010?
Provide a short and direct response. 0. What is the ratio of the Rent(as % of GDP) in Europe(all income levels) in 2006 to that in 2011?
Provide a short and direct response. 0.29. What is the ratio of the Rent(as % of GDP) in Low income in 2006 to that in 2011?
Your response must be concise. 0.33. What is the ratio of the Rent(as % of GDP) in Kazakhstan in 2006 to that in 2011?
Ensure brevity in your answer.  0.59. What is the ratio of the Rent(as % of GDP) of Romania in 2006 to that in 2011?
Provide a succinct answer. 0. What is the ratio of the Rent(as % of GDP) in Europe(all income levels) in 2007 to that in 2008?
Ensure brevity in your answer.  0.37. What is the ratio of the Rent(as % of GDP) of Low income in 2007 to that in 2008?
Provide a short and direct response. 0.51. What is the ratio of the Rent(as % of GDP) of Kazakhstan in 2007 to that in 2008?
Your response must be concise. 0.45. What is the ratio of the Rent(as % of GDP) in Romania in 2007 to that in 2008?
Offer a terse response. 0. What is the ratio of the Rent(as % of GDP) of Low income in 2007 to that in 2009?
Ensure brevity in your answer.  1.43. What is the ratio of the Rent(as % of GDP) in Kazakhstan in 2007 to that in 2009?
Keep it short and to the point. 1.05. What is the ratio of the Rent(as % of GDP) in Romania in 2007 to that in 2009?
Provide a succinct answer. 1. What is the ratio of the Rent(as % of GDP) of Europe(all income levels) in 2007 to that in 2010?
Provide a short and direct response. 0.54. What is the ratio of the Rent(as % of GDP) of Low income in 2007 to that in 2010?
Your response must be concise. 0.75. What is the ratio of the Rent(as % of GDP) in Kazakhstan in 2007 to that in 2010?
Provide a short and direct response. 0.77. What is the ratio of the Rent(as % of GDP) in Romania in 2007 to that in 2010?
Offer a very short reply. 0. What is the ratio of the Rent(as % of GDP) in Europe(all income levels) in 2007 to that in 2011?
Your answer should be compact. 0.39. What is the ratio of the Rent(as % of GDP) of Low income in 2007 to that in 2011?
Keep it short and to the point. 0.48. What is the ratio of the Rent(as % of GDP) of Kazakhstan in 2007 to that in 2011?
Provide a short and direct response. 0.67. What is the ratio of the Rent(as % of GDP) of Romania in 2007 to that in 2011?
Keep it short and to the point. 0. What is the ratio of the Rent(as % of GDP) of Europe(all income levels) in 2008 to that in 2009?
Give a very brief answer. 2.72. What is the ratio of the Rent(as % of GDP) in Low income in 2008 to that in 2009?
Give a very brief answer. 2.78. What is the ratio of the Rent(as % of GDP) in Kazakhstan in 2008 to that in 2009?
Make the answer very short. 2.33. What is the ratio of the Rent(as % of GDP) in Romania in 2008 to that in 2009?
Provide a succinct answer. 903.21. What is the ratio of the Rent(as % of GDP) in Europe(all income levels) in 2008 to that in 2010?
Provide a short and direct response. 1.46. What is the ratio of the Rent(as % of GDP) of Low income in 2008 to that in 2010?
Provide a succinct answer. 1.46. What is the ratio of the Rent(as % of GDP) of Kazakhstan in 2008 to that in 2010?
Keep it short and to the point. 1.73. What is the ratio of the Rent(as % of GDP) of Romania in 2008 to that in 2010?
Your response must be concise. 3.91. What is the ratio of the Rent(as % of GDP) of Europe(all income levels) in 2008 to that in 2011?
Provide a short and direct response. 1.05. What is the ratio of the Rent(as % of GDP) in Low income in 2008 to that in 2011?
Make the answer very short. 0.94. What is the ratio of the Rent(as % of GDP) of Kazakhstan in 2008 to that in 2011?
Your response must be concise. 1.5. What is the ratio of the Rent(as % of GDP) of Romania in 2008 to that in 2011?
Your answer should be compact. 0.87. What is the ratio of the Rent(as % of GDP) in Europe(all income levels) in 2009 to that in 2010?
Ensure brevity in your answer.  0.54. What is the ratio of the Rent(as % of GDP) of Low income in 2009 to that in 2010?
Your answer should be compact. 0.52. What is the ratio of the Rent(as % of GDP) of Kazakhstan in 2009 to that in 2010?
Your answer should be very brief. 0.74. What is the ratio of the Rent(as % of GDP) in Romania in 2009 to that in 2010?
Provide a short and direct response. 0. What is the ratio of the Rent(as % of GDP) in Europe(all income levels) in 2009 to that in 2011?
Provide a short and direct response. 0.39. What is the ratio of the Rent(as % of GDP) of Low income in 2009 to that in 2011?
Your answer should be compact. 0.34. What is the ratio of the Rent(as % of GDP) of Kazakhstan in 2009 to that in 2011?
Your answer should be very brief. 0.64. What is the ratio of the Rent(as % of GDP) of Romania in 2009 to that in 2011?
Give a very brief answer. 0. What is the ratio of the Rent(as % of GDP) in Europe(all income levels) in 2010 to that in 2011?
Provide a short and direct response. 0.72. What is the ratio of the Rent(as % of GDP) of Low income in 2010 to that in 2011?
Offer a very short reply. 0.64. What is the ratio of the Rent(as % of GDP) in Kazakhstan in 2010 to that in 2011?
Provide a short and direct response. 0.87. What is the ratio of the Rent(as % of GDP) of Romania in 2010 to that in 2011?
Offer a terse response. 0.22. What is the difference between the highest and the second highest Rent(as % of GDP) in Europe(all income levels)?
Your response must be concise. 0.01. What is the difference between the highest and the second highest Rent(as % of GDP) in Low income?
Make the answer very short. 0.01. What is the difference between the highest and the second highest Rent(as % of GDP) of Kazakhstan?
Provide a succinct answer. 1.83. What is the difference between the highest and the second highest Rent(as % of GDP) of Romania?
Offer a terse response. 0.01. What is the difference between the highest and the lowest Rent(as % of GDP) of Europe(all income levels)?
Provide a succinct answer. 0.16. What is the difference between the highest and the lowest Rent(as % of GDP) of Low income?
Provide a short and direct response. 0.09. What is the difference between the highest and the lowest Rent(as % of GDP) in Kazakhstan?
Keep it short and to the point. 3.32. What is the difference between the highest and the lowest Rent(as % of GDP) of Romania?
Provide a short and direct response. 0.1. 